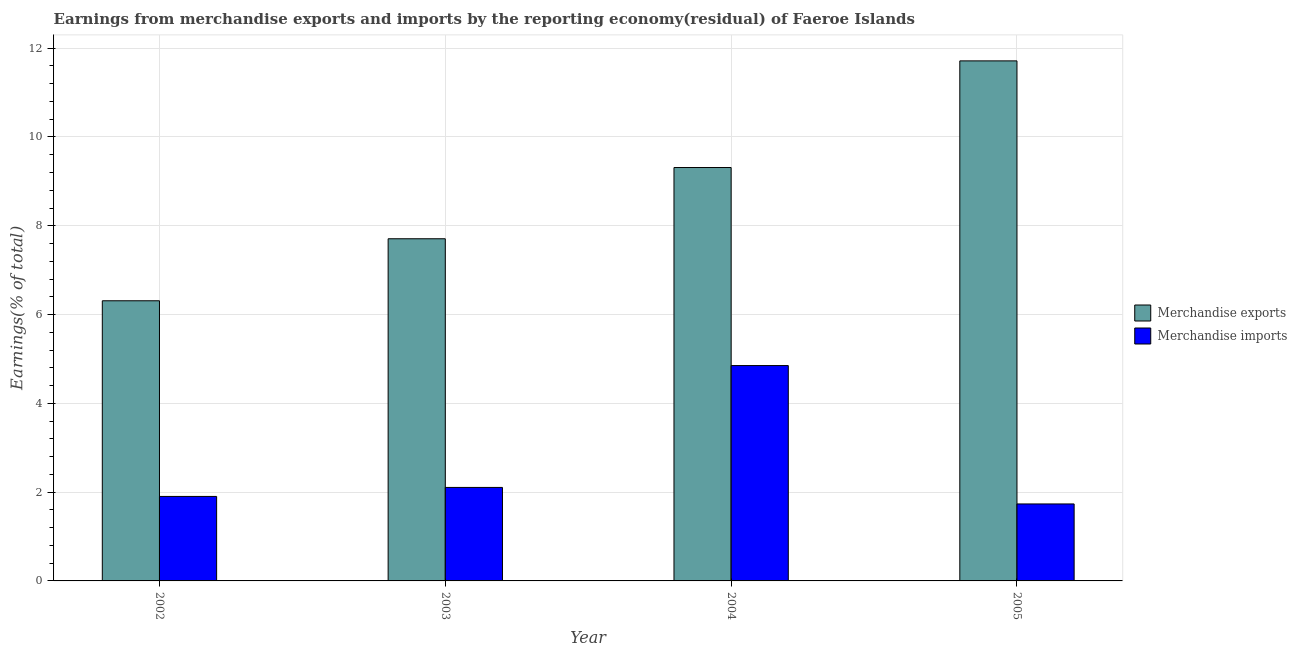How many bars are there on the 3rd tick from the right?
Provide a succinct answer. 2. In how many cases, is the number of bars for a given year not equal to the number of legend labels?
Ensure brevity in your answer.  0. What is the earnings from merchandise exports in 2005?
Offer a very short reply. 11.71. Across all years, what is the maximum earnings from merchandise imports?
Provide a succinct answer. 4.85. Across all years, what is the minimum earnings from merchandise imports?
Keep it short and to the point. 1.73. In which year was the earnings from merchandise imports maximum?
Offer a terse response. 2004. What is the total earnings from merchandise imports in the graph?
Provide a short and direct response. 10.59. What is the difference between the earnings from merchandise exports in 2003 and that in 2004?
Offer a terse response. -1.6. What is the difference between the earnings from merchandise exports in 2003 and the earnings from merchandise imports in 2005?
Your answer should be compact. -4.01. What is the average earnings from merchandise imports per year?
Make the answer very short. 2.65. In the year 2005, what is the difference between the earnings from merchandise imports and earnings from merchandise exports?
Your answer should be very brief. 0. In how many years, is the earnings from merchandise exports greater than 6.8 %?
Your answer should be very brief. 3. What is the ratio of the earnings from merchandise exports in 2003 to that in 2005?
Offer a terse response. 0.66. Is the difference between the earnings from merchandise imports in 2003 and 2005 greater than the difference between the earnings from merchandise exports in 2003 and 2005?
Your response must be concise. No. What is the difference between the highest and the second highest earnings from merchandise imports?
Your answer should be very brief. 2.74. What is the difference between the highest and the lowest earnings from merchandise imports?
Your response must be concise. 3.12. How many bars are there?
Your response must be concise. 8. Are all the bars in the graph horizontal?
Offer a very short reply. No. Are the values on the major ticks of Y-axis written in scientific E-notation?
Keep it short and to the point. No. Does the graph contain any zero values?
Offer a terse response. No. Where does the legend appear in the graph?
Provide a succinct answer. Center right. How are the legend labels stacked?
Keep it short and to the point. Vertical. What is the title of the graph?
Ensure brevity in your answer.  Earnings from merchandise exports and imports by the reporting economy(residual) of Faeroe Islands. Does "Underweight" appear as one of the legend labels in the graph?
Offer a terse response. No. What is the label or title of the Y-axis?
Keep it short and to the point. Earnings(% of total). What is the Earnings(% of total) of Merchandise exports in 2002?
Provide a succinct answer. 6.31. What is the Earnings(% of total) in Merchandise imports in 2002?
Provide a short and direct response. 1.9. What is the Earnings(% of total) in Merchandise exports in 2003?
Your response must be concise. 7.71. What is the Earnings(% of total) of Merchandise imports in 2003?
Your answer should be compact. 2.11. What is the Earnings(% of total) in Merchandise exports in 2004?
Offer a terse response. 9.31. What is the Earnings(% of total) in Merchandise imports in 2004?
Provide a short and direct response. 4.85. What is the Earnings(% of total) in Merchandise exports in 2005?
Make the answer very short. 11.71. What is the Earnings(% of total) of Merchandise imports in 2005?
Your answer should be very brief. 1.73. Across all years, what is the maximum Earnings(% of total) of Merchandise exports?
Provide a succinct answer. 11.71. Across all years, what is the maximum Earnings(% of total) in Merchandise imports?
Give a very brief answer. 4.85. Across all years, what is the minimum Earnings(% of total) in Merchandise exports?
Your answer should be very brief. 6.31. Across all years, what is the minimum Earnings(% of total) in Merchandise imports?
Your response must be concise. 1.73. What is the total Earnings(% of total) in Merchandise exports in the graph?
Make the answer very short. 35.04. What is the total Earnings(% of total) of Merchandise imports in the graph?
Your response must be concise. 10.59. What is the difference between the Earnings(% of total) in Merchandise exports in 2002 and that in 2003?
Your answer should be very brief. -1.4. What is the difference between the Earnings(% of total) in Merchandise imports in 2002 and that in 2003?
Provide a short and direct response. -0.2. What is the difference between the Earnings(% of total) in Merchandise exports in 2002 and that in 2004?
Provide a succinct answer. -3. What is the difference between the Earnings(% of total) of Merchandise imports in 2002 and that in 2004?
Give a very brief answer. -2.95. What is the difference between the Earnings(% of total) of Merchandise exports in 2002 and that in 2005?
Ensure brevity in your answer.  -5.4. What is the difference between the Earnings(% of total) of Merchandise imports in 2002 and that in 2005?
Offer a terse response. 0.17. What is the difference between the Earnings(% of total) of Merchandise exports in 2003 and that in 2004?
Provide a succinct answer. -1.6. What is the difference between the Earnings(% of total) in Merchandise imports in 2003 and that in 2004?
Ensure brevity in your answer.  -2.75. What is the difference between the Earnings(% of total) in Merchandise exports in 2003 and that in 2005?
Keep it short and to the point. -4.01. What is the difference between the Earnings(% of total) in Merchandise imports in 2003 and that in 2005?
Your answer should be compact. 0.37. What is the difference between the Earnings(% of total) of Merchandise exports in 2004 and that in 2005?
Make the answer very short. -2.4. What is the difference between the Earnings(% of total) in Merchandise imports in 2004 and that in 2005?
Make the answer very short. 3.12. What is the difference between the Earnings(% of total) of Merchandise exports in 2002 and the Earnings(% of total) of Merchandise imports in 2003?
Ensure brevity in your answer.  4.2. What is the difference between the Earnings(% of total) of Merchandise exports in 2002 and the Earnings(% of total) of Merchandise imports in 2004?
Offer a terse response. 1.46. What is the difference between the Earnings(% of total) of Merchandise exports in 2002 and the Earnings(% of total) of Merchandise imports in 2005?
Your answer should be compact. 4.58. What is the difference between the Earnings(% of total) in Merchandise exports in 2003 and the Earnings(% of total) in Merchandise imports in 2004?
Offer a terse response. 2.86. What is the difference between the Earnings(% of total) of Merchandise exports in 2003 and the Earnings(% of total) of Merchandise imports in 2005?
Your response must be concise. 5.97. What is the difference between the Earnings(% of total) in Merchandise exports in 2004 and the Earnings(% of total) in Merchandise imports in 2005?
Your answer should be very brief. 7.58. What is the average Earnings(% of total) of Merchandise exports per year?
Make the answer very short. 8.76. What is the average Earnings(% of total) of Merchandise imports per year?
Give a very brief answer. 2.65. In the year 2002, what is the difference between the Earnings(% of total) in Merchandise exports and Earnings(% of total) in Merchandise imports?
Provide a succinct answer. 4.41. In the year 2003, what is the difference between the Earnings(% of total) in Merchandise exports and Earnings(% of total) in Merchandise imports?
Offer a terse response. 5.6. In the year 2004, what is the difference between the Earnings(% of total) of Merchandise exports and Earnings(% of total) of Merchandise imports?
Offer a very short reply. 4.46. In the year 2005, what is the difference between the Earnings(% of total) in Merchandise exports and Earnings(% of total) in Merchandise imports?
Ensure brevity in your answer.  9.98. What is the ratio of the Earnings(% of total) of Merchandise exports in 2002 to that in 2003?
Offer a terse response. 0.82. What is the ratio of the Earnings(% of total) of Merchandise imports in 2002 to that in 2003?
Provide a short and direct response. 0.9. What is the ratio of the Earnings(% of total) of Merchandise exports in 2002 to that in 2004?
Keep it short and to the point. 0.68. What is the ratio of the Earnings(% of total) of Merchandise imports in 2002 to that in 2004?
Give a very brief answer. 0.39. What is the ratio of the Earnings(% of total) in Merchandise exports in 2002 to that in 2005?
Offer a terse response. 0.54. What is the ratio of the Earnings(% of total) in Merchandise imports in 2002 to that in 2005?
Provide a succinct answer. 1.1. What is the ratio of the Earnings(% of total) in Merchandise exports in 2003 to that in 2004?
Your response must be concise. 0.83. What is the ratio of the Earnings(% of total) in Merchandise imports in 2003 to that in 2004?
Your answer should be compact. 0.43. What is the ratio of the Earnings(% of total) in Merchandise exports in 2003 to that in 2005?
Offer a terse response. 0.66. What is the ratio of the Earnings(% of total) in Merchandise imports in 2003 to that in 2005?
Offer a very short reply. 1.21. What is the ratio of the Earnings(% of total) in Merchandise exports in 2004 to that in 2005?
Your answer should be very brief. 0.79. What is the ratio of the Earnings(% of total) in Merchandise imports in 2004 to that in 2005?
Offer a very short reply. 2.8. What is the difference between the highest and the second highest Earnings(% of total) in Merchandise exports?
Your answer should be very brief. 2.4. What is the difference between the highest and the second highest Earnings(% of total) of Merchandise imports?
Give a very brief answer. 2.75. What is the difference between the highest and the lowest Earnings(% of total) in Merchandise exports?
Offer a very short reply. 5.4. What is the difference between the highest and the lowest Earnings(% of total) in Merchandise imports?
Offer a very short reply. 3.12. 